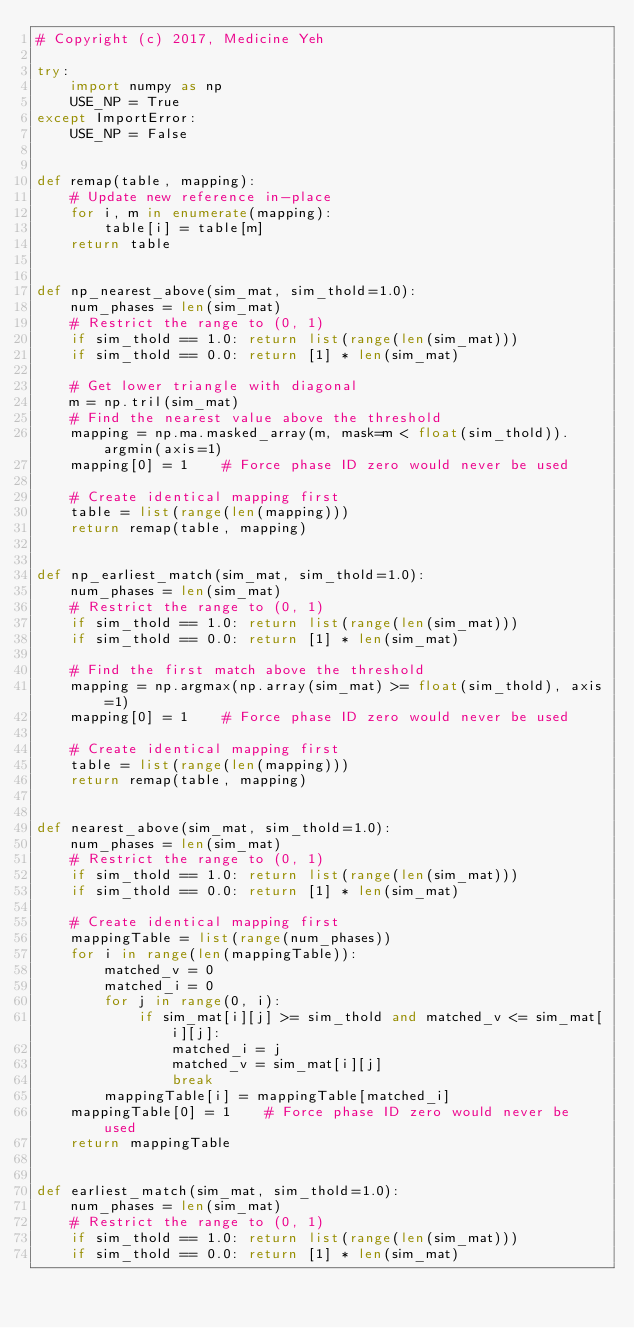Convert code to text. <code><loc_0><loc_0><loc_500><loc_500><_Python_># Copyright (c) 2017, Medicine Yeh

try:
    import numpy as np
    USE_NP = True
except ImportError:
    USE_NP = False


def remap(table, mapping):
    # Update new reference in-place
    for i, m in enumerate(mapping):
        table[i] = table[m]
    return table


def np_nearest_above(sim_mat, sim_thold=1.0):
    num_phases = len(sim_mat)
    # Restrict the range to (0, 1)
    if sim_thold == 1.0: return list(range(len(sim_mat)))
    if sim_thold == 0.0: return [1] * len(sim_mat)

    # Get lower triangle with diagonal
    m = np.tril(sim_mat)
    # Find the nearest value above the threshold
    mapping = np.ma.masked_array(m, mask=m < float(sim_thold)).argmin(axis=1)
    mapping[0] = 1    # Force phase ID zero would never be used

    # Create identical mapping first
    table = list(range(len(mapping)))
    return remap(table, mapping)


def np_earliest_match(sim_mat, sim_thold=1.0):
    num_phases = len(sim_mat)
    # Restrict the range to (0, 1)
    if sim_thold == 1.0: return list(range(len(sim_mat)))
    if sim_thold == 0.0: return [1] * len(sim_mat)

    # Find the first match above the threshold
    mapping = np.argmax(np.array(sim_mat) >= float(sim_thold), axis=1)
    mapping[0] = 1    # Force phase ID zero would never be used

    # Create identical mapping first
    table = list(range(len(mapping)))
    return remap(table, mapping)


def nearest_above(sim_mat, sim_thold=1.0):
    num_phases = len(sim_mat)
    # Restrict the range to (0, 1)
    if sim_thold == 1.0: return list(range(len(sim_mat)))
    if sim_thold == 0.0: return [1] * len(sim_mat)

    # Create identical mapping first
    mappingTable = list(range(num_phases))
    for i in range(len(mappingTable)):
        matched_v = 0
        matched_i = 0
        for j in range(0, i):
            if sim_mat[i][j] >= sim_thold and matched_v <= sim_mat[i][j]:
                matched_i = j
                matched_v = sim_mat[i][j]
                break
        mappingTable[i] = mappingTable[matched_i]
    mappingTable[0] = 1    # Force phase ID zero would never be used
    return mappingTable


def earliest_match(sim_mat, sim_thold=1.0):
    num_phases = len(sim_mat)
    # Restrict the range to (0, 1)
    if sim_thold == 1.0: return list(range(len(sim_mat)))
    if sim_thold == 0.0: return [1] * len(sim_mat)
</code> 